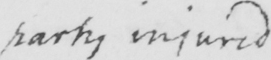Please provide the text content of this handwritten line. party injured 